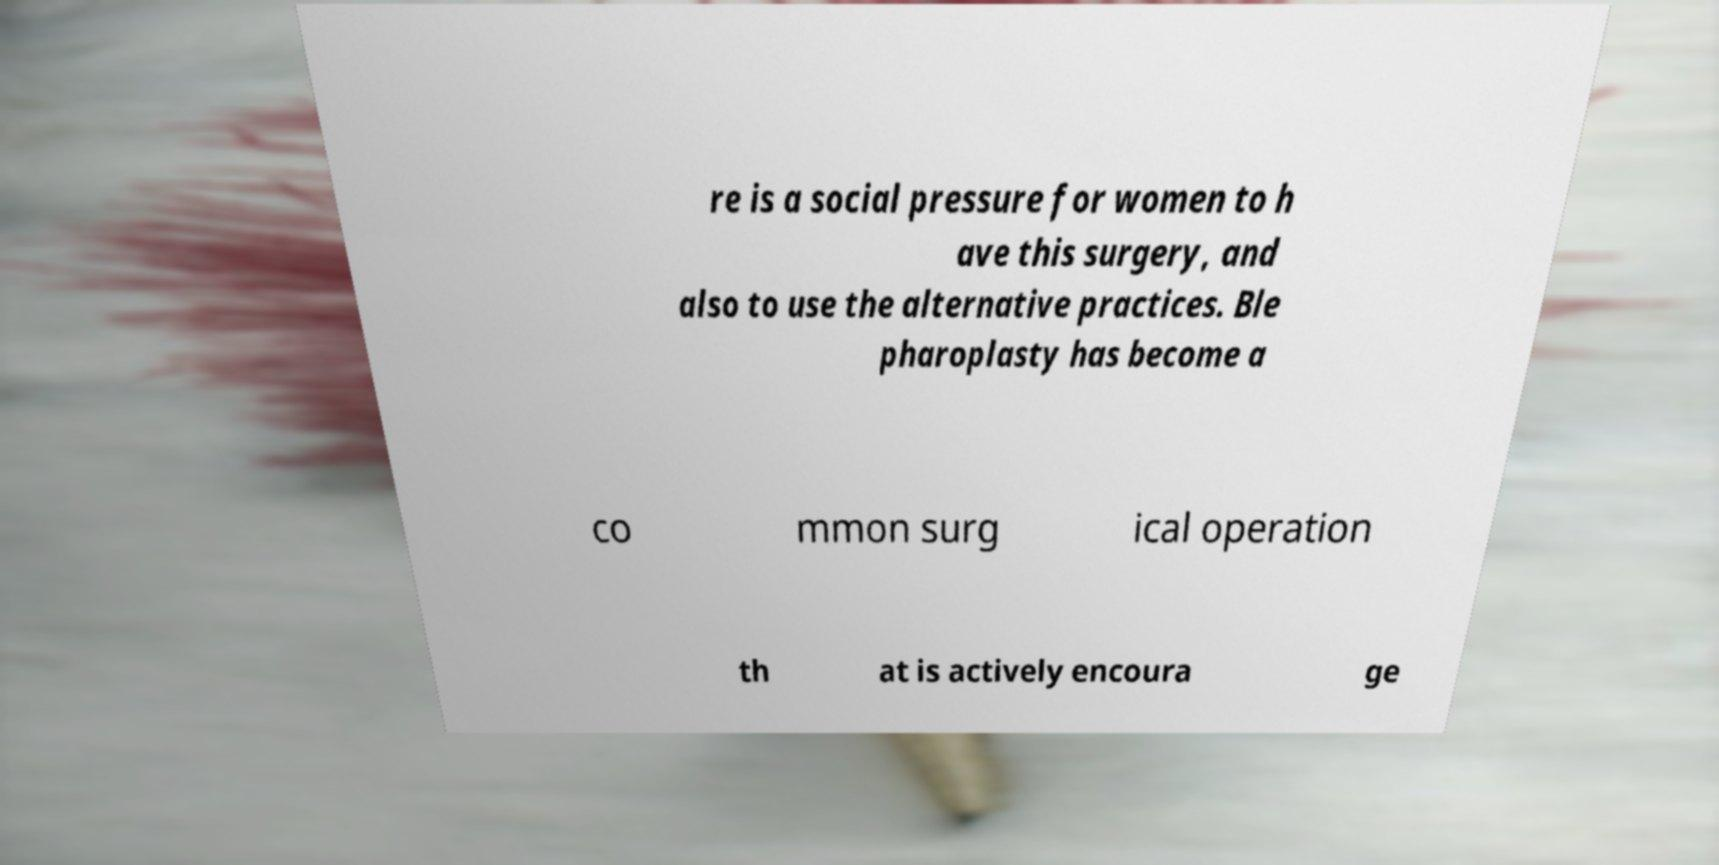Can you accurately transcribe the text from the provided image for me? re is a social pressure for women to h ave this surgery, and also to use the alternative practices. Ble pharoplasty has become a co mmon surg ical operation th at is actively encoura ge 